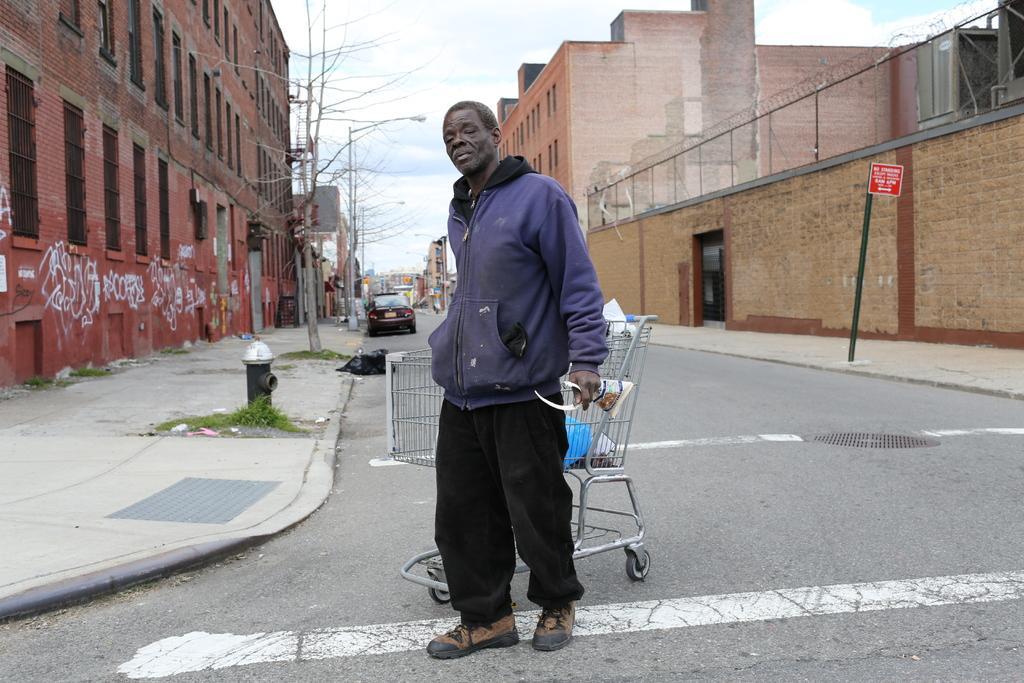Could you give a brief overview of what you see in this image? In this image, we can see a person who is holding an object and he is standing on the road. On the left and right side, we can see some buildings and poles. There are trees on the left side. There are also some cars on the road. In the background, we can see the sky. 